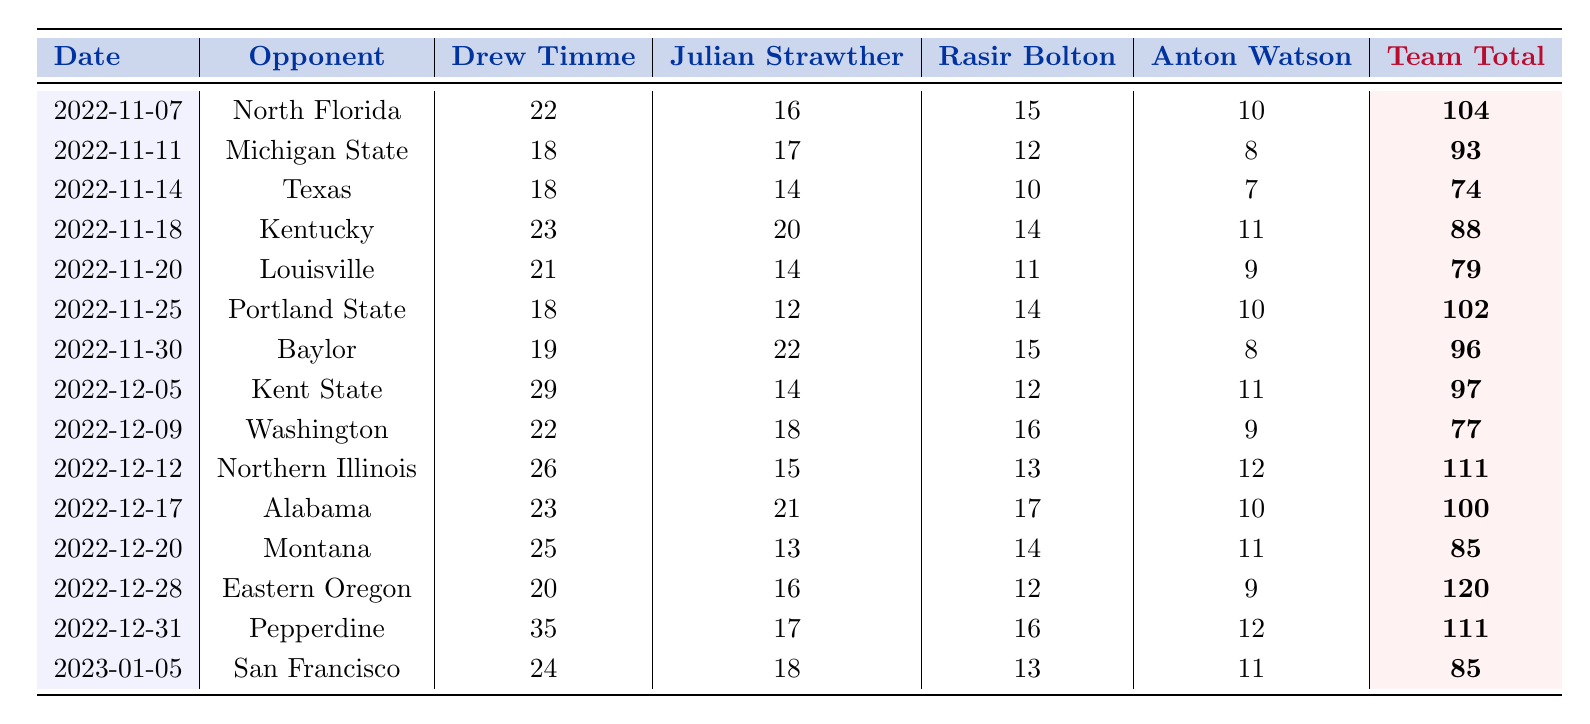What was the highest team total scored in a game? The highest team total in a game can be found by looking through the "Team Total" column for the maximum value. The highest value is 120, which occurred against Eastern Oregon on December 28, 2022.
Answer: 120 How many points did Drew Timme score in the game against Alabama? By checking the row corresponding to the game against Alabama on December 17, 2022, Drew Timme's score is listed as 23.
Answer: 23 What was the difference in points scored by Julian Strawther between the game against North Florida and the game against Pepperdine? Julian Strawther scored 16 points against North Florida and 17 points against Pepperdine. The difference is calculated as 17 - 16 = 1.
Answer: 1 Did Rasir Bolton ever score more than 15 points in a game? By reviewing the values in the "Rasir Bolton" column, it can be seen that he scored above 15 points in multiple games. Therefore, the answer is yes.
Answer: Yes What was Drew Timme's average scoring across all games listed? To calculate the average, sum all of Drew Timme's points (22 + 18 + 18 + 23 + 21 + 18 + 19 + 29 + 22 + 26 + 23 + 25 + 20 + 35 + 24 =  366) and divide by the number of games (15). Thus, the average is 366 / 15 = 24.4.
Answer: 24.4 Which game had the lowest score by Rasir Bolton? The lowest score by Rasir Bolton can be identified by scanning the "Rasir Bolton" column for the minimum value, which is 10 points scored in the game against Texas on November 14, 2022.
Answer: 10 How many players scored over 20 points in the game against Eastern Oregon? In the row for the game against Eastern Oregon on December 28, 2022, Drew Timme (20), Julian Strawther (16), and Rasir Bolton (12) are noted. Only Drew Timme scored over 20 points, so the total is one player.
Answer: 1 Was there a game where all players listed scored in double digits? Checking each game will help determine if all scores are in double digits. For the game against Kentucky on November 18, 2022, all players scored in double digits, confirming the statement as true.
Answer: Yes What was the total points scored by Anton Watson against Louisville? In the game against Louisville on November 20, 2022, Anton Watson scored 9 points, as listed in the corresponding row.
Answer: 9 How many total points did the team score in the last game listed against San Francisco? The "Team Total" for the last game against San Francisco on January 5, 2023, is 85, as indicated in that row.
Answer: 85 